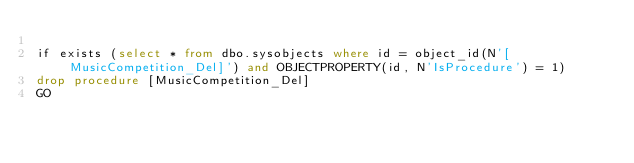Convert code to text. <code><loc_0><loc_0><loc_500><loc_500><_SQL_>
if exists (select * from dbo.sysobjects where id = object_id(N'[MusicCompetition_Del]') and OBJECTPROPERTY(id, N'IsProcedure') = 1)
drop procedure [MusicCompetition_Del]
GO


</code> 